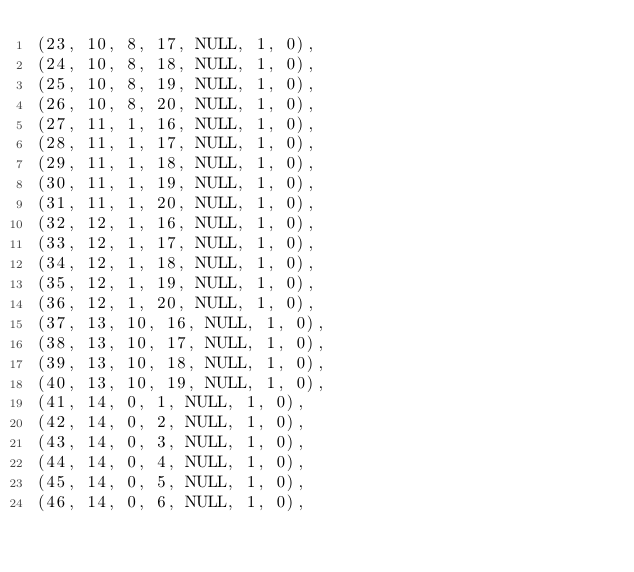<code> <loc_0><loc_0><loc_500><loc_500><_SQL_>(23, 10, 8, 17, NULL, 1, 0),
(24, 10, 8, 18, NULL, 1, 0),
(25, 10, 8, 19, NULL, 1, 0),
(26, 10, 8, 20, NULL, 1, 0),
(27, 11, 1, 16, NULL, 1, 0),
(28, 11, 1, 17, NULL, 1, 0),
(29, 11, 1, 18, NULL, 1, 0),
(30, 11, 1, 19, NULL, 1, 0),
(31, 11, 1, 20, NULL, 1, 0),
(32, 12, 1, 16, NULL, 1, 0),
(33, 12, 1, 17, NULL, 1, 0),
(34, 12, 1, 18, NULL, 1, 0),
(35, 12, 1, 19, NULL, 1, 0),
(36, 12, 1, 20, NULL, 1, 0),
(37, 13, 10, 16, NULL, 1, 0),
(38, 13, 10, 17, NULL, 1, 0),
(39, 13, 10, 18, NULL, 1, 0),
(40, 13, 10, 19, NULL, 1, 0),
(41, 14, 0, 1, NULL, 1, 0),
(42, 14, 0, 2, NULL, 1, 0),
(43, 14, 0, 3, NULL, 1, 0),
(44, 14, 0, 4, NULL, 1, 0),
(45, 14, 0, 5, NULL, 1, 0),
(46, 14, 0, 6, NULL, 1, 0),</code> 